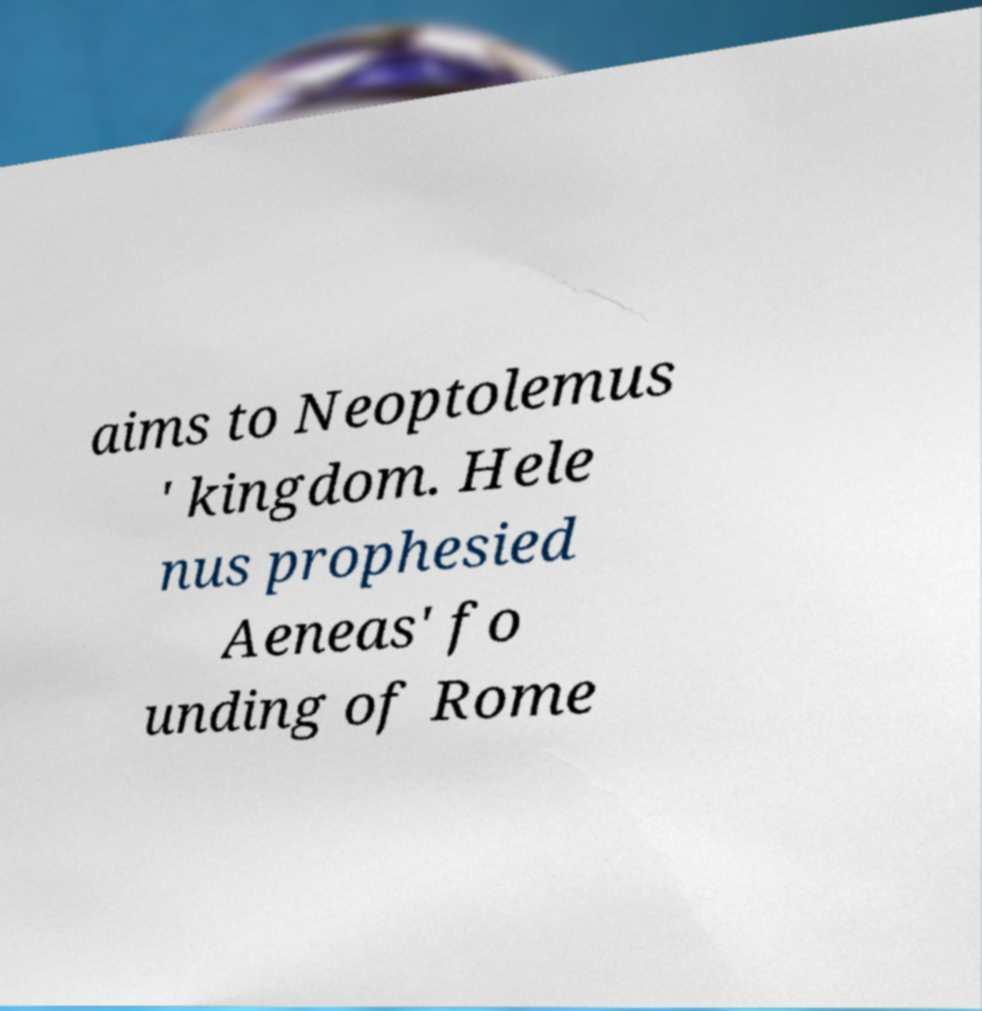Can you accurately transcribe the text from the provided image for me? aims to Neoptolemus ' kingdom. Hele nus prophesied Aeneas' fo unding of Rome 